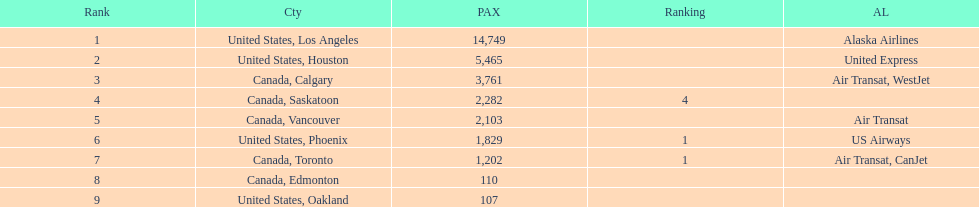The difference in passengers between los angeles and toronto 13,547. 